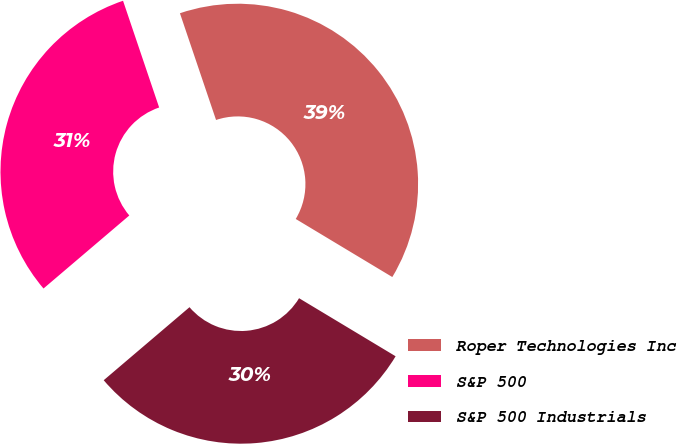<chart> <loc_0><loc_0><loc_500><loc_500><pie_chart><fcel>Roper Technologies Inc<fcel>S&P 500<fcel>S&P 500 Industrials<nl><fcel>38.81%<fcel>31.03%<fcel>30.16%<nl></chart> 